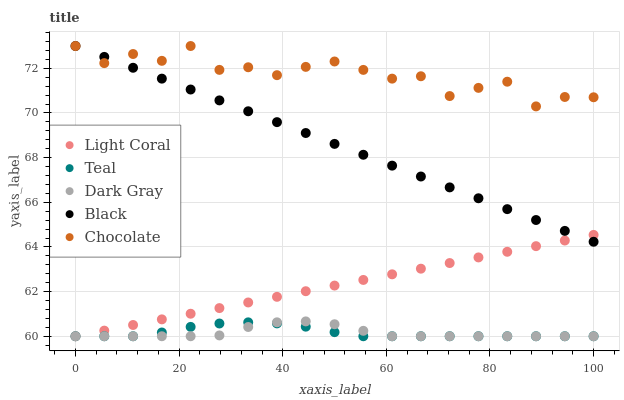Does Dark Gray have the minimum area under the curve?
Answer yes or no. Yes. Does Chocolate have the maximum area under the curve?
Answer yes or no. Yes. Does Black have the minimum area under the curve?
Answer yes or no. No. Does Black have the maximum area under the curve?
Answer yes or no. No. Is Light Coral the smoothest?
Answer yes or no. Yes. Is Chocolate the roughest?
Answer yes or no. Yes. Is Dark Gray the smoothest?
Answer yes or no. No. Is Dark Gray the roughest?
Answer yes or no. No. Does Light Coral have the lowest value?
Answer yes or no. Yes. Does Black have the lowest value?
Answer yes or no. No. Does Chocolate have the highest value?
Answer yes or no. Yes. Does Dark Gray have the highest value?
Answer yes or no. No. Is Teal less than Chocolate?
Answer yes or no. Yes. Is Chocolate greater than Teal?
Answer yes or no. Yes. Does Black intersect Chocolate?
Answer yes or no. Yes. Is Black less than Chocolate?
Answer yes or no. No. Is Black greater than Chocolate?
Answer yes or no. No. Does Teal intersect Chocolate?
Answer yes or no. No. 